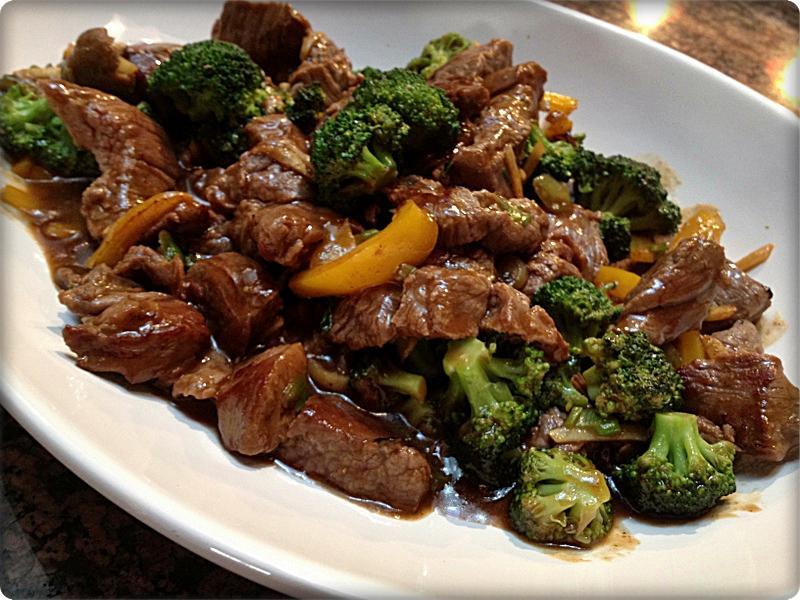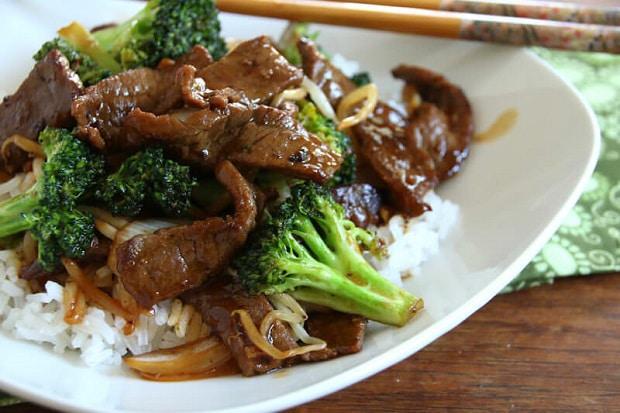The first image is the image on the left, the second image is the image on the right. Examine the images to the left and right. Is the description "Meat and brocolli is served over rice." accurate? Answer yes or no. Yes. The first image is the image on the left, the second image is the image on the right. Examine the images to the left and right. Is the description "Two beef and broccoli meals are served on white plates, one with rice and one with no rice." accurate? Answer yes or no. Yes. 